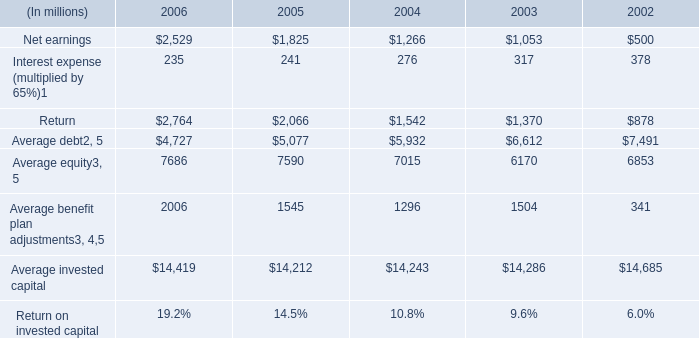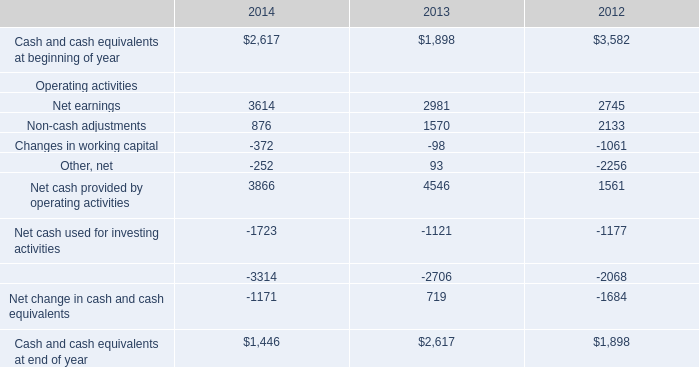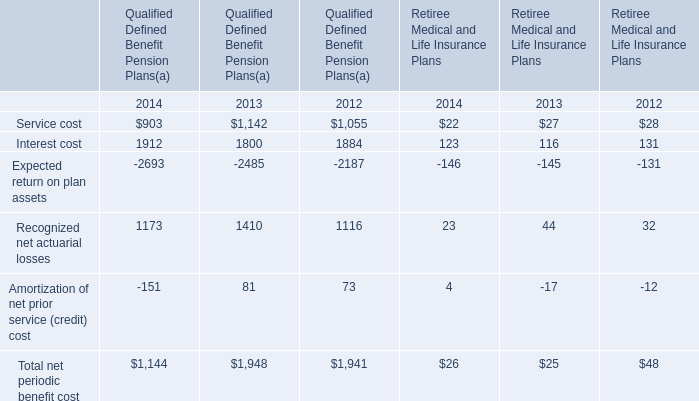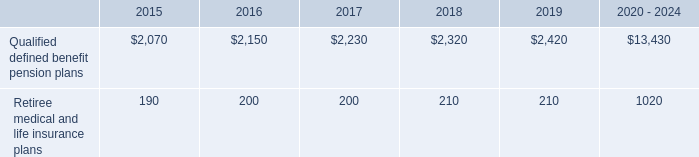what was the average of company 401 ( k ) match total for the three years ended 2014 , in millions? 
Computations: (((385 + 383) + 380) / 3)
Answer: 382.66667. 